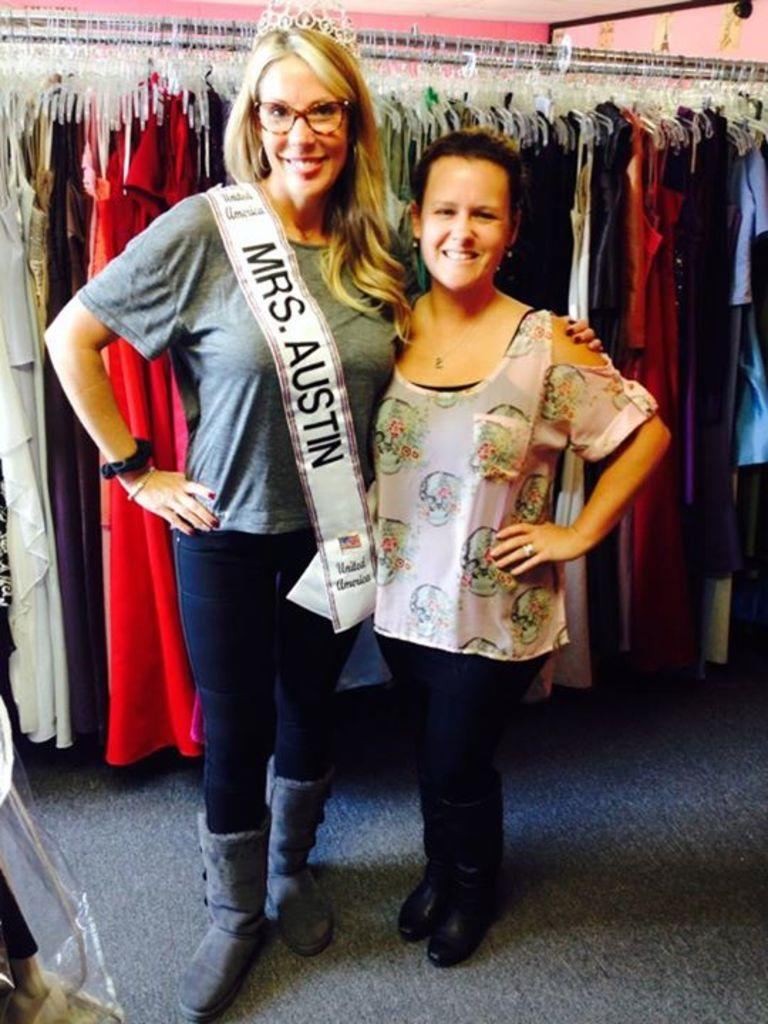What is the surface that the people are standing on in the image? The people are standing on a carpet in the image. What can be seen in the background of the image? There are clothes and a wall visible in the background of the image. What type of toe is used to hold the clothes in the image? There is no toe present in the image, and the clothes are not being held by any toe. 